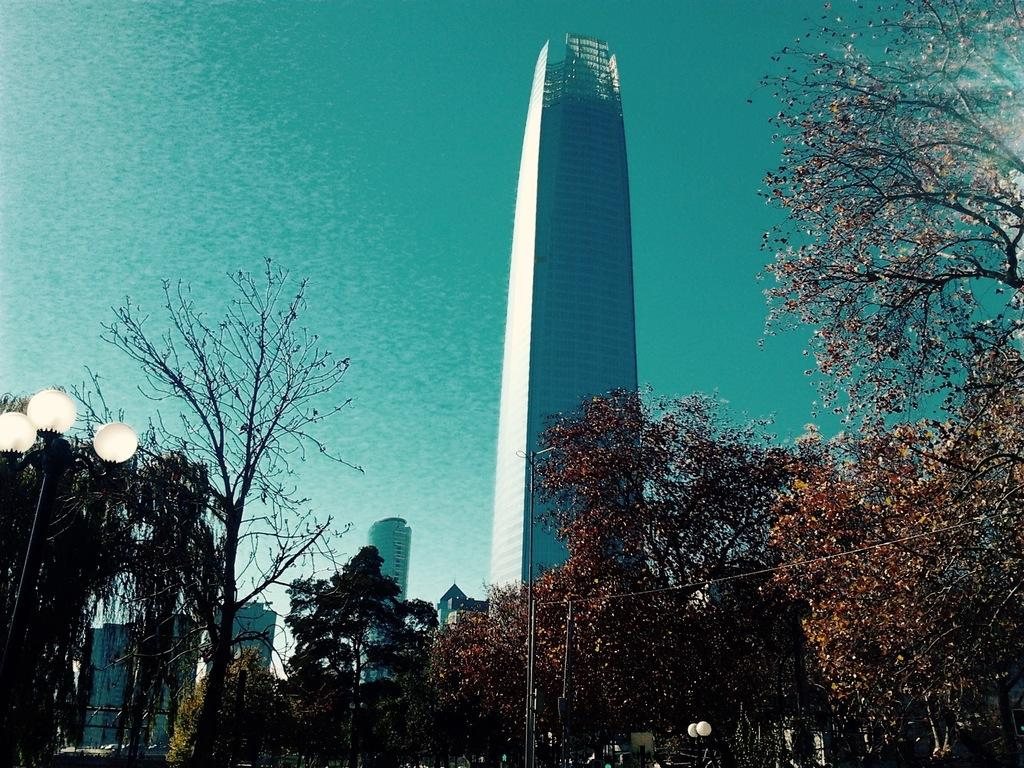What type of structures can be seen in the image? There are buildings in the image. What natural elements are present in the image? There are trees in the image. What man-made objects can be seen in the image? There are poles in the image. What utility infrastructure is visible in the image? Electric wires are visible in the image. What part of the natural environment is visible in the image? The sky is visible in the image. What type of knowledge can be gained from the kettle in the image? There is no kettle present in the image, so no knowledge can be gained from it. 